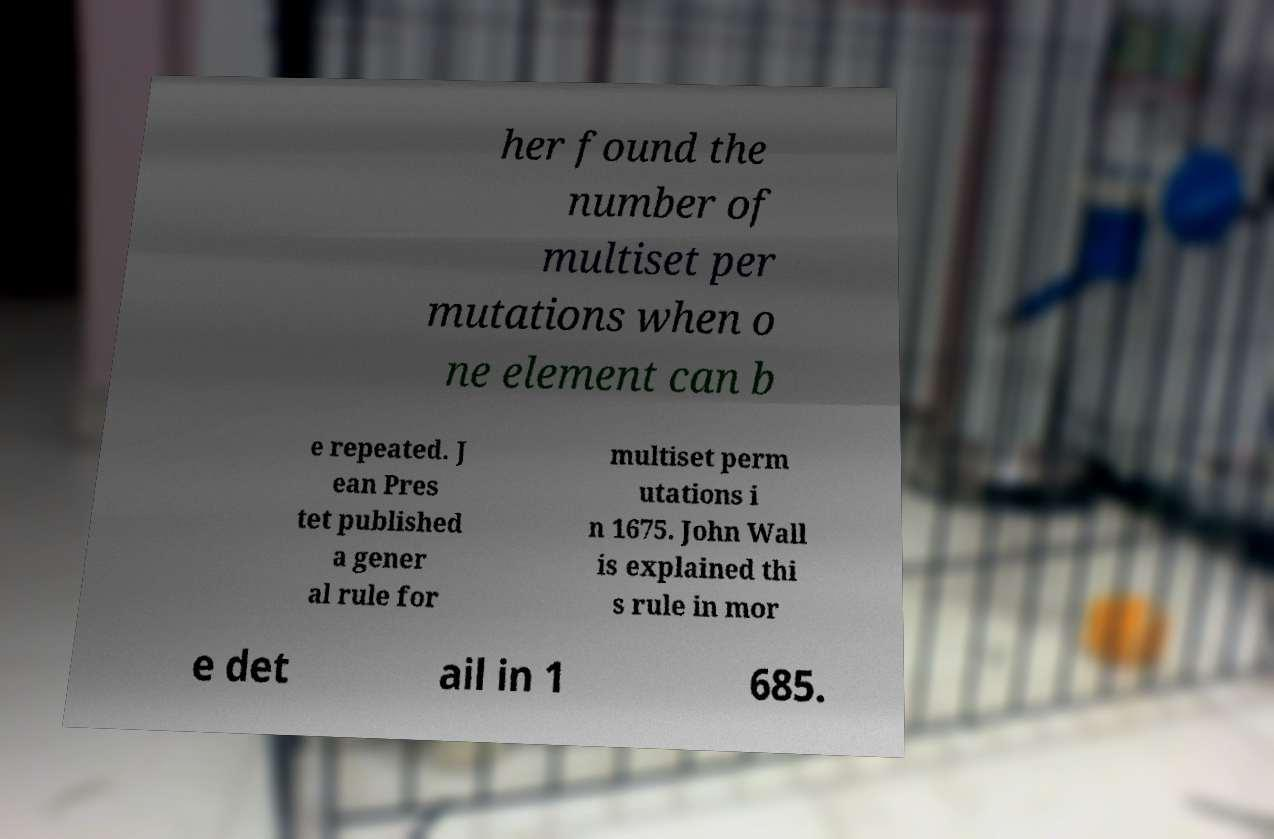Could you assist in decoding the text presented in this image and type it out clearly? her found the number of multiset per mutations when o ne element can b e repeated. J ean Pres tet published a gener al rule for multiset perm utations i n 1675. John Wall is explained thi s rule in mor e det ail in 1 685. 